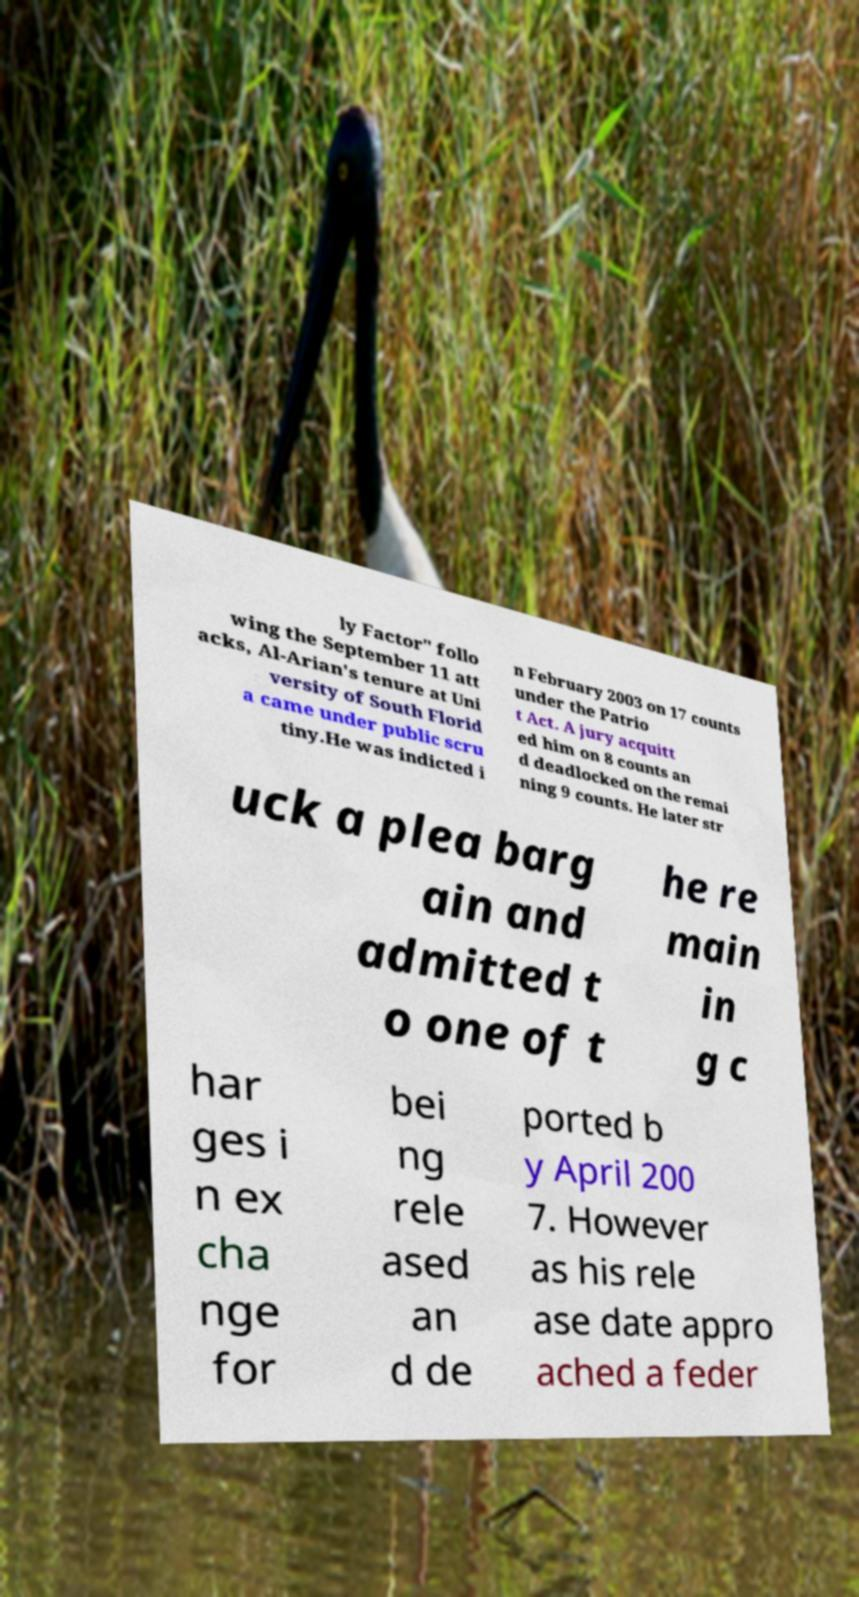Can you read and provide the text displayed in the image?This photo seems to have some interesting text. Can you extract and type it out for me? ly Factor" follo wing the September 11 att acks, Al-Arian's tenure at Uni versity of South Florid a came under public scru tiny.He was indicted i n February 2003 on 17 counts under the Patrio t Act. A jury acquitt ed him on 8 counts an d deadlocked on the remai ning 9 counts. He later str uck a plea barg ain and admitted t o one of t he re main in g c har ges i n ex cha nge for bei ng rele ased an d de ported b y April 200 7. However as his rele ase date appro ached a feder 